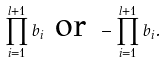<formula> <loc_0><loc_0><loc_500><loc_500>\prod _ { i = 1 } ^ { l + 1 } b _ { i } \text { or } - \prod _ { i = 1 } ^ { l + 1 } b _ { i } .</formula> 